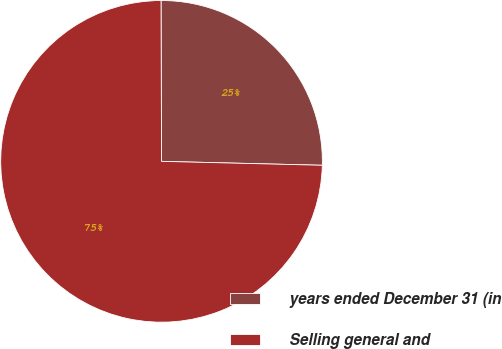<chart> <loc_0><loc_0><loc_500><loc_500><pie_chart><fcel>years ended December 31 (in<fcel>Selling general and<nl><fcel>25.44%<fcel>74.56%<nl></chart> 